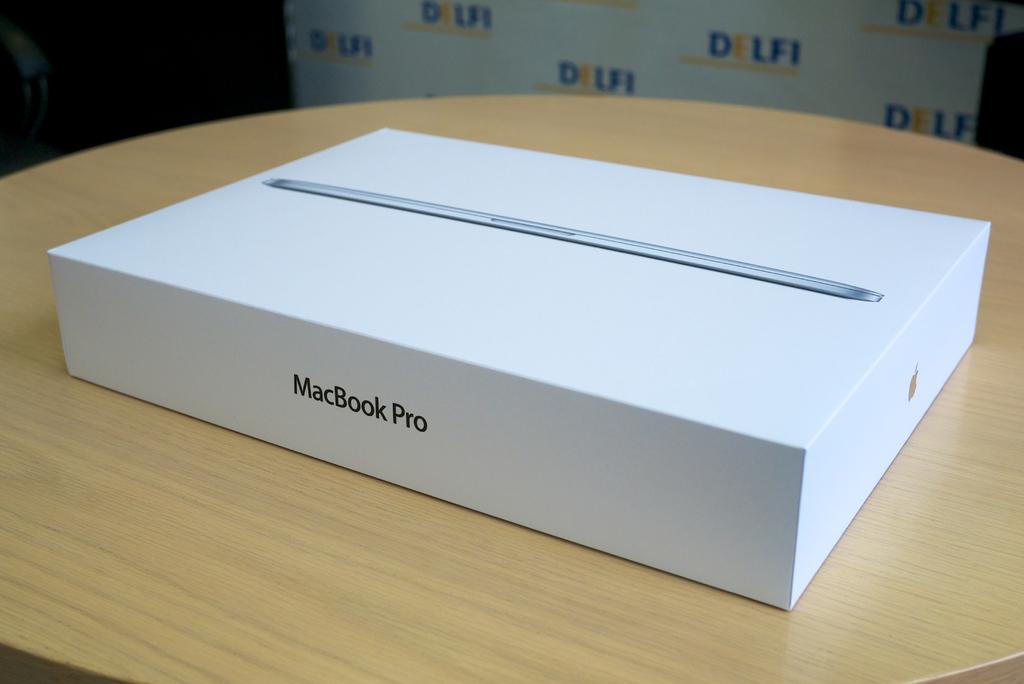What is the name of the laptop in the box?
Provide a succinct answer. Macbook pro. What word is repeated on the wall?
Provide a succinct answer. Delfi. 